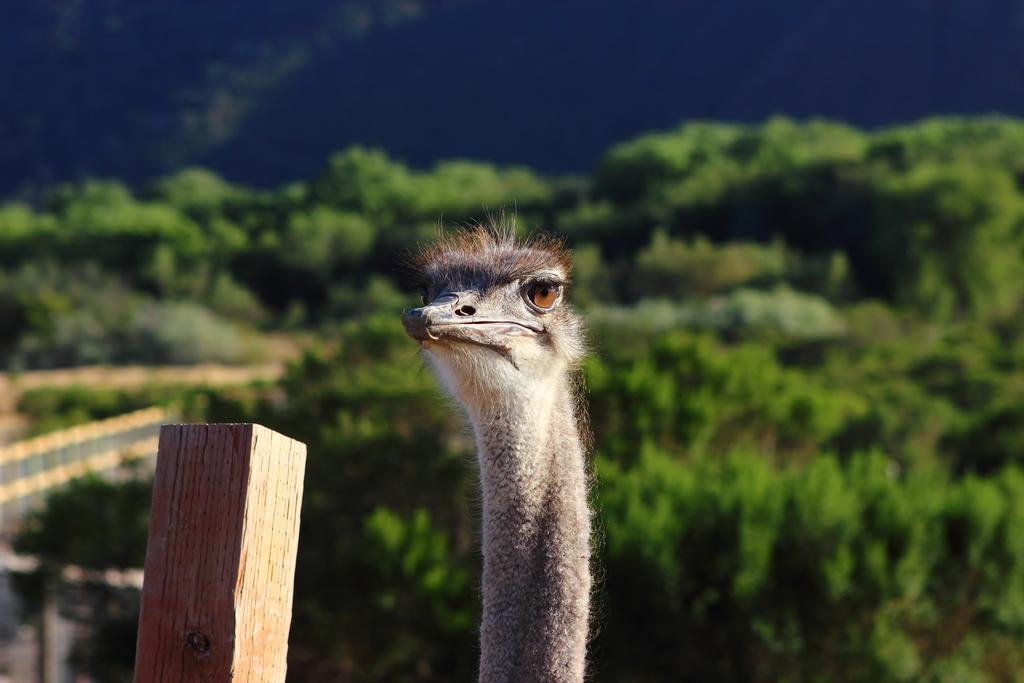What type of animal can be seen in the image? There is a bird in the image. What object is present in the image alongside the bird? There is a wooden stick in the image. What can be seen in the background of the image? Trees and the sky are visible in the background of the image. What type of salt can be seen on the map in the image? There is no salt or map present in the image; it features a bird and a wooden stick with trees and the sky in the background. 